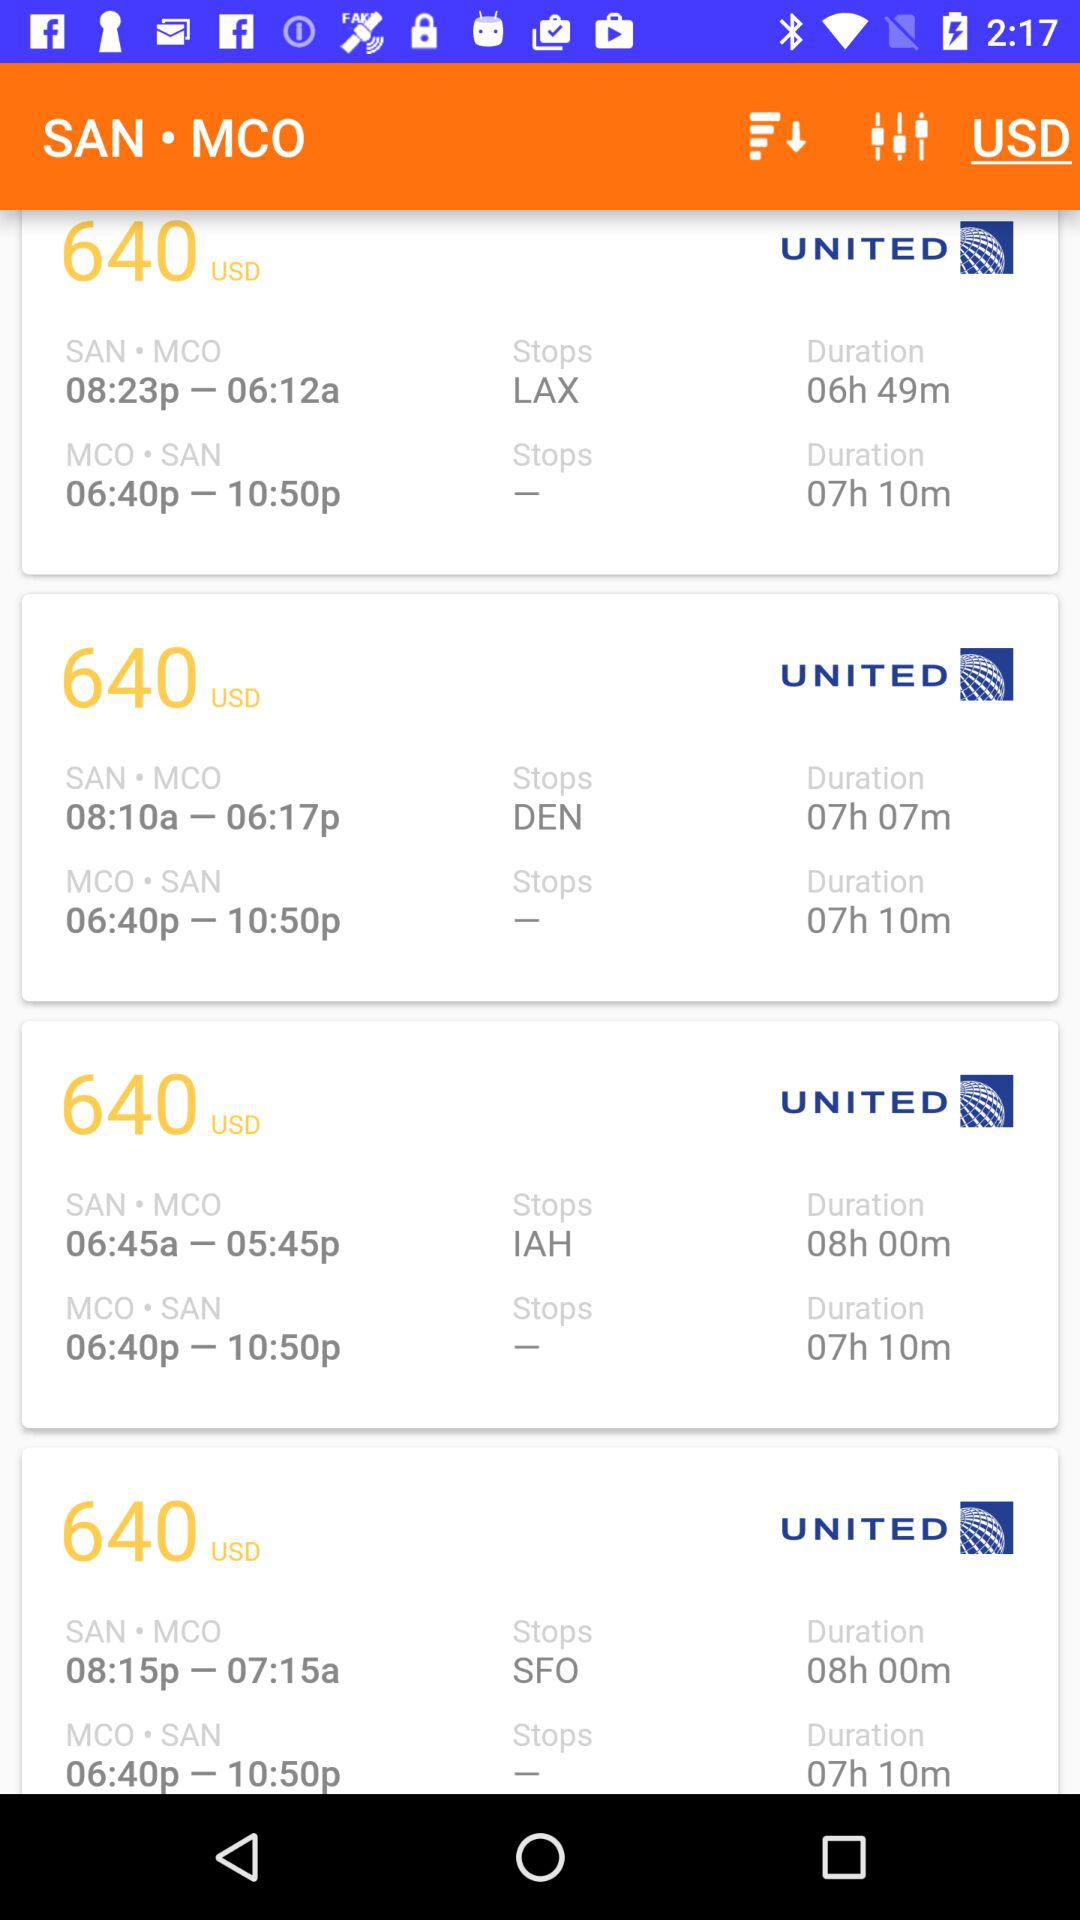What is the time duration of the journey whose stop is LAX? The time duration of the journey is 6 hours and 49 minutes. 